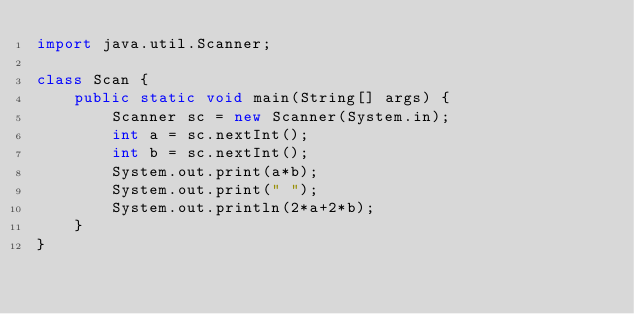Convert code to text. <code><loc_0><loc_0><loc_500><loc_500><_Java_>import java.util.Scanner;
 
class Scan {
    public static void main(String[] args) {
        Scanner sc = new Scanner(System.in);
        int a = sc.nextInt();
        int b = sc.nextInt();
        System.out.print(a*b);
        System.out.print(" ");
        System.out.println(2*a+2*b);
    }
}
 </code> 